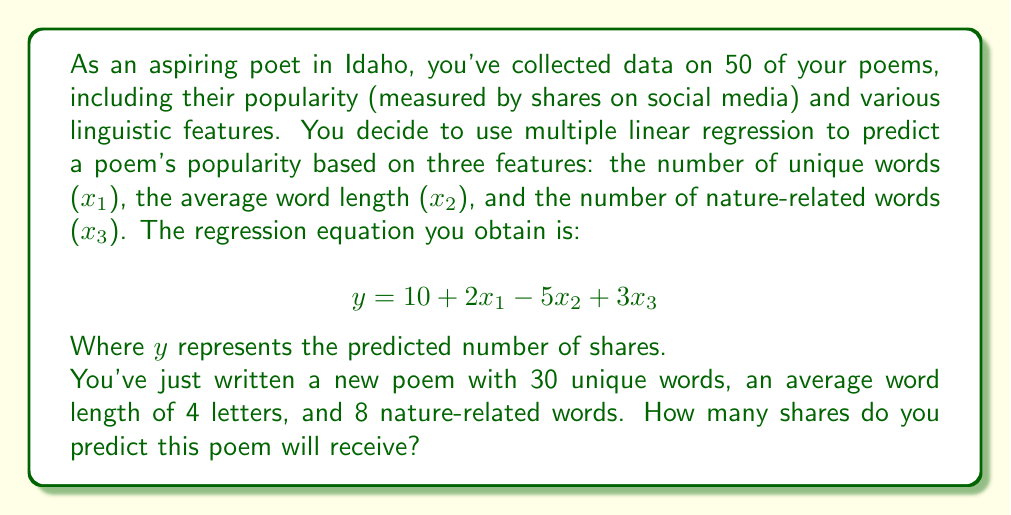Can you solve this math problem? To solve this problem, we'll follow these steps:

1. Identify the given information:
   - Regression equation: $y = 10 + 2x_1 - 5x_2 + 3x_3$
   - $x_1$ (number of unique words) = 30
   - $x_2$ (average word length) = 4
   - $x_3$ (number of nature-related words) = 8

2. Substitute the values into the regression equation:
   $y = 10 + 2(30) - 5(4) + 3(8)$

3. Calculate each term:
   $y = 10 + 60 - 20 + 24$

4. Sum up all the terms:
   $y = 74$

Therefore, based on the regression model, we predict that the new poem will receive 74 shares on social media.
Answer: 74 shares 